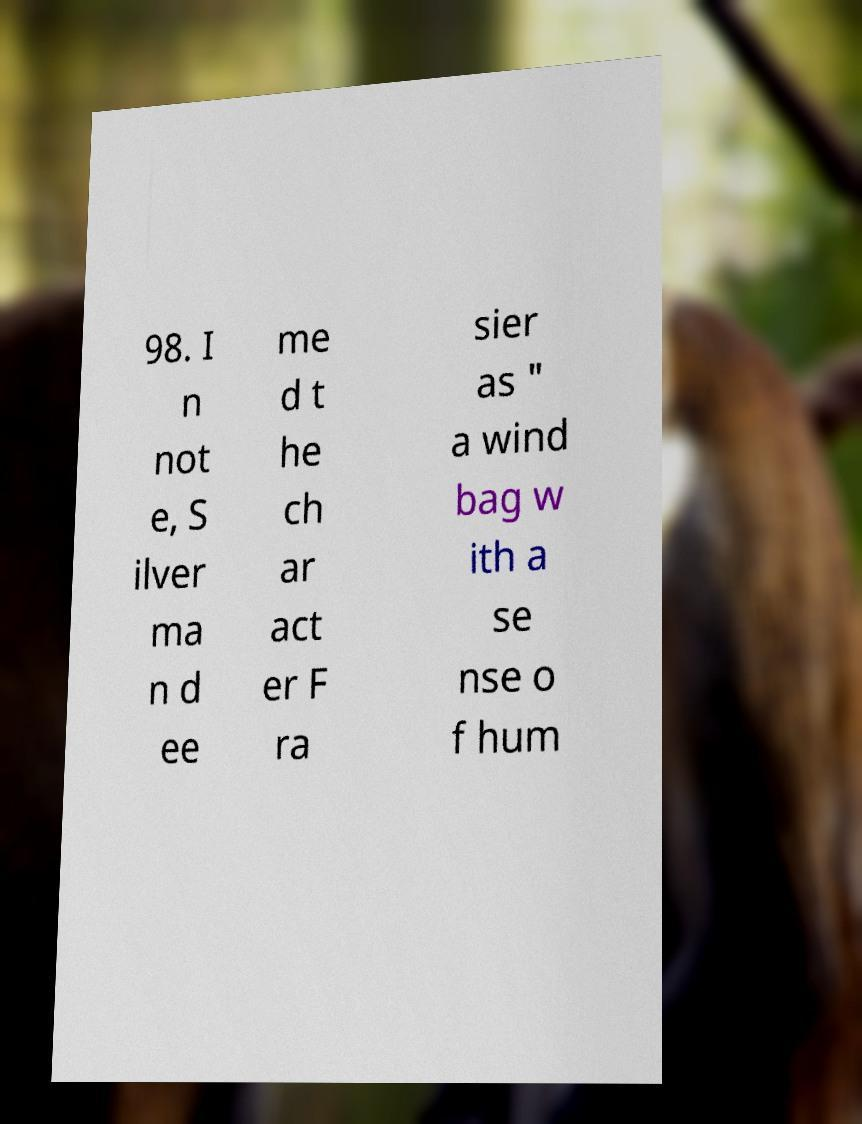For documentation purposes, I need the text within this image transcribed. Could you provide that? 98. I n not e, S ilver ma n d ee me d t he ch ar act er F ra sier as " a wind bag w ith a se nse o f hum 